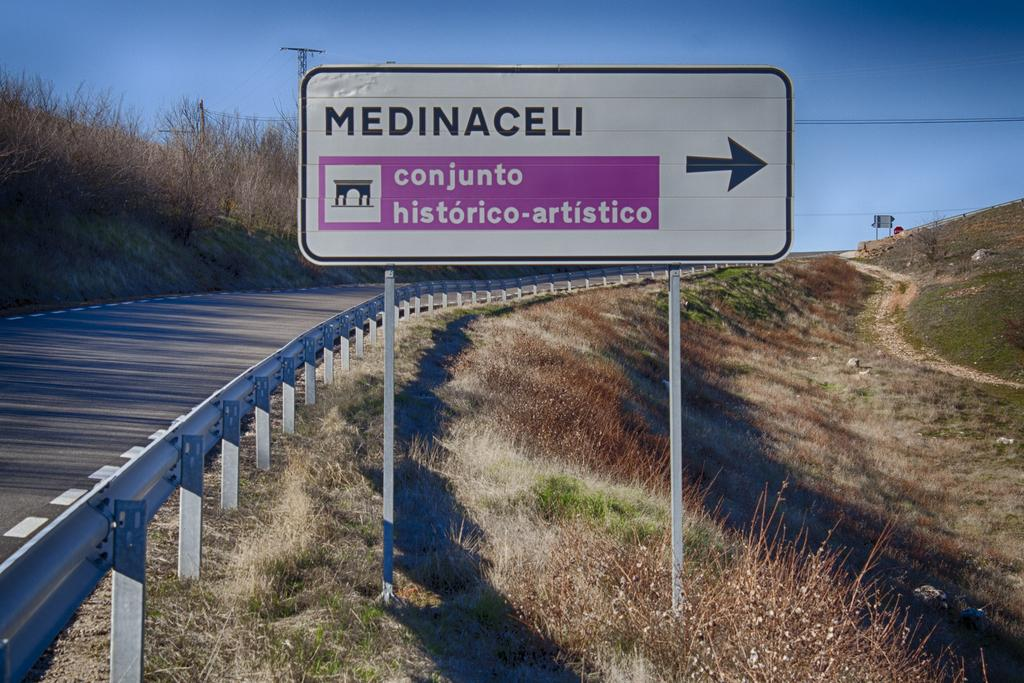<image>
Relay a brief, clear account of the picture shown. a medinaceli sign that has an arrow on it 